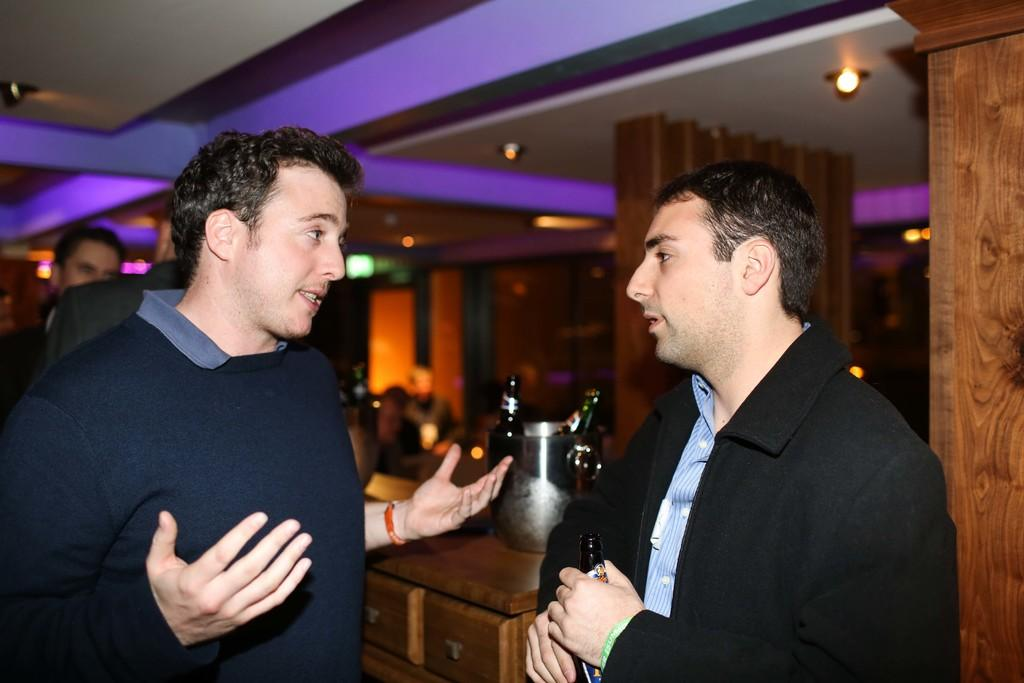What is the person on the right side of the image holding? The person is holding a glass bottle. What can be seen on the left side of the image? There are people on the left side of the image. What is illuminated in the image? There are lights visible in the image. What type of dress is the edge of the image wearing? There is no dress or edge of the image present in the image. What kind of apparel is visible on the people in the image? The provided facts do not mention any specific apparel worn by the people in the image. 